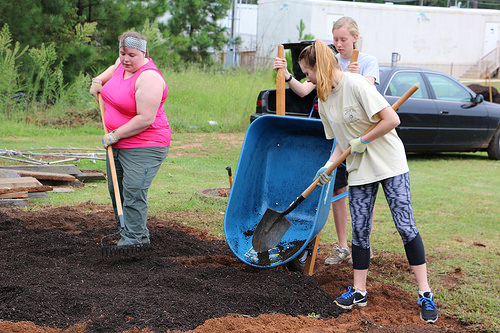<image>
Can you confirm if the fertilizer is under the shovel? Yes. The fertilizer is positioned underneath the shovel, with the shovel above it in the vertical space. Is the wheel barrel behind the shovel? Yes. From this viewpoint, the wheel barrel is positioned behind the shovel, with the shovel partially or fully occluding the wheel barrel. 